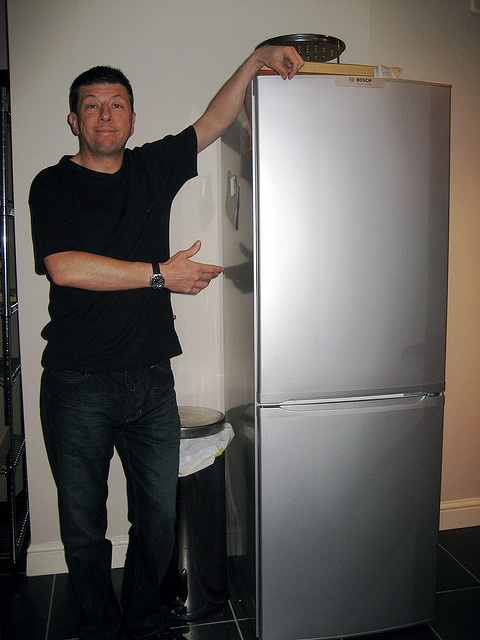Describe the objects in this image and their specific colors. I can see refrigerator in black, gray, darkgray, and lightgray tones, people in black, brown, darkgray, and gray tones, and clock in black, gray, darkgray, and lightgray tones in this image. 